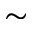<formula> <loc_0><loc_0><loc_500><loc_500>\sim</formula> 